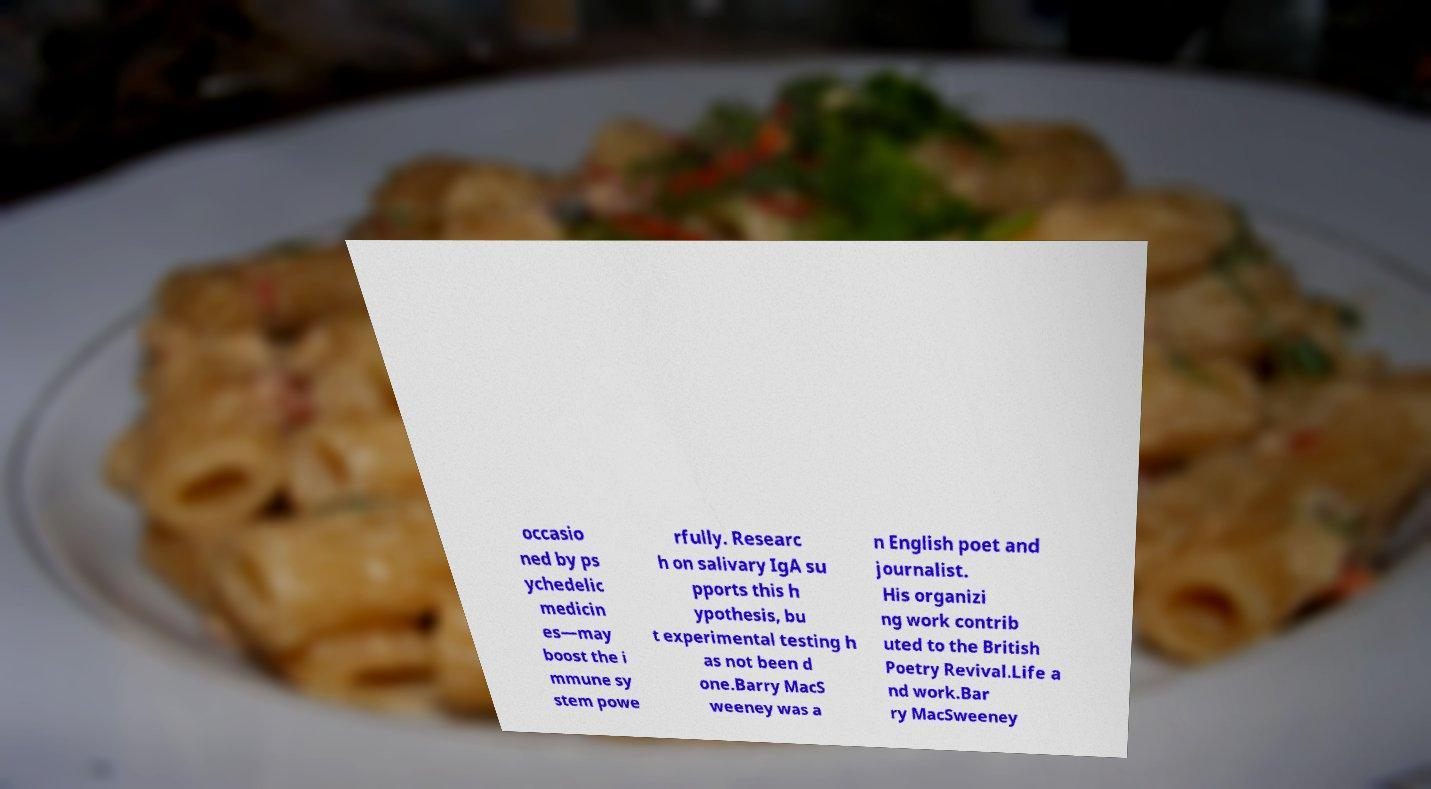Please identify and transcribe the text found in this image. occasio ned by ps ychedelic medicin es—may boost the i mmune sy stem powe rfully. Researc h on salivary IgA su pports this h ypothesis, bu t experimental testing h as not been d one.Barry MacS weeney was a n English poet and journalist. His organizi ng work contrib uted to the British Poetry Revival.Life a nd work.Bar ry MacSweeney 